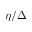Convert formula to latex. <formula><loc_0><loc_0><loc_500><loc_500>\eta / \Delta</formula> 